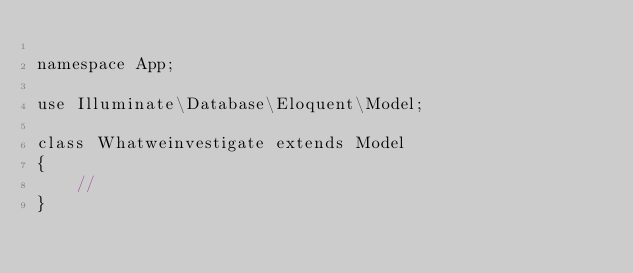<code> <loc_0><loc_0><loc_500><loc_500><_PHP_>
namespace App;

use Illuminate\Database\Eloquent\Model;

class Whatweinvestigate extends Model
{
    //
}
</code> 